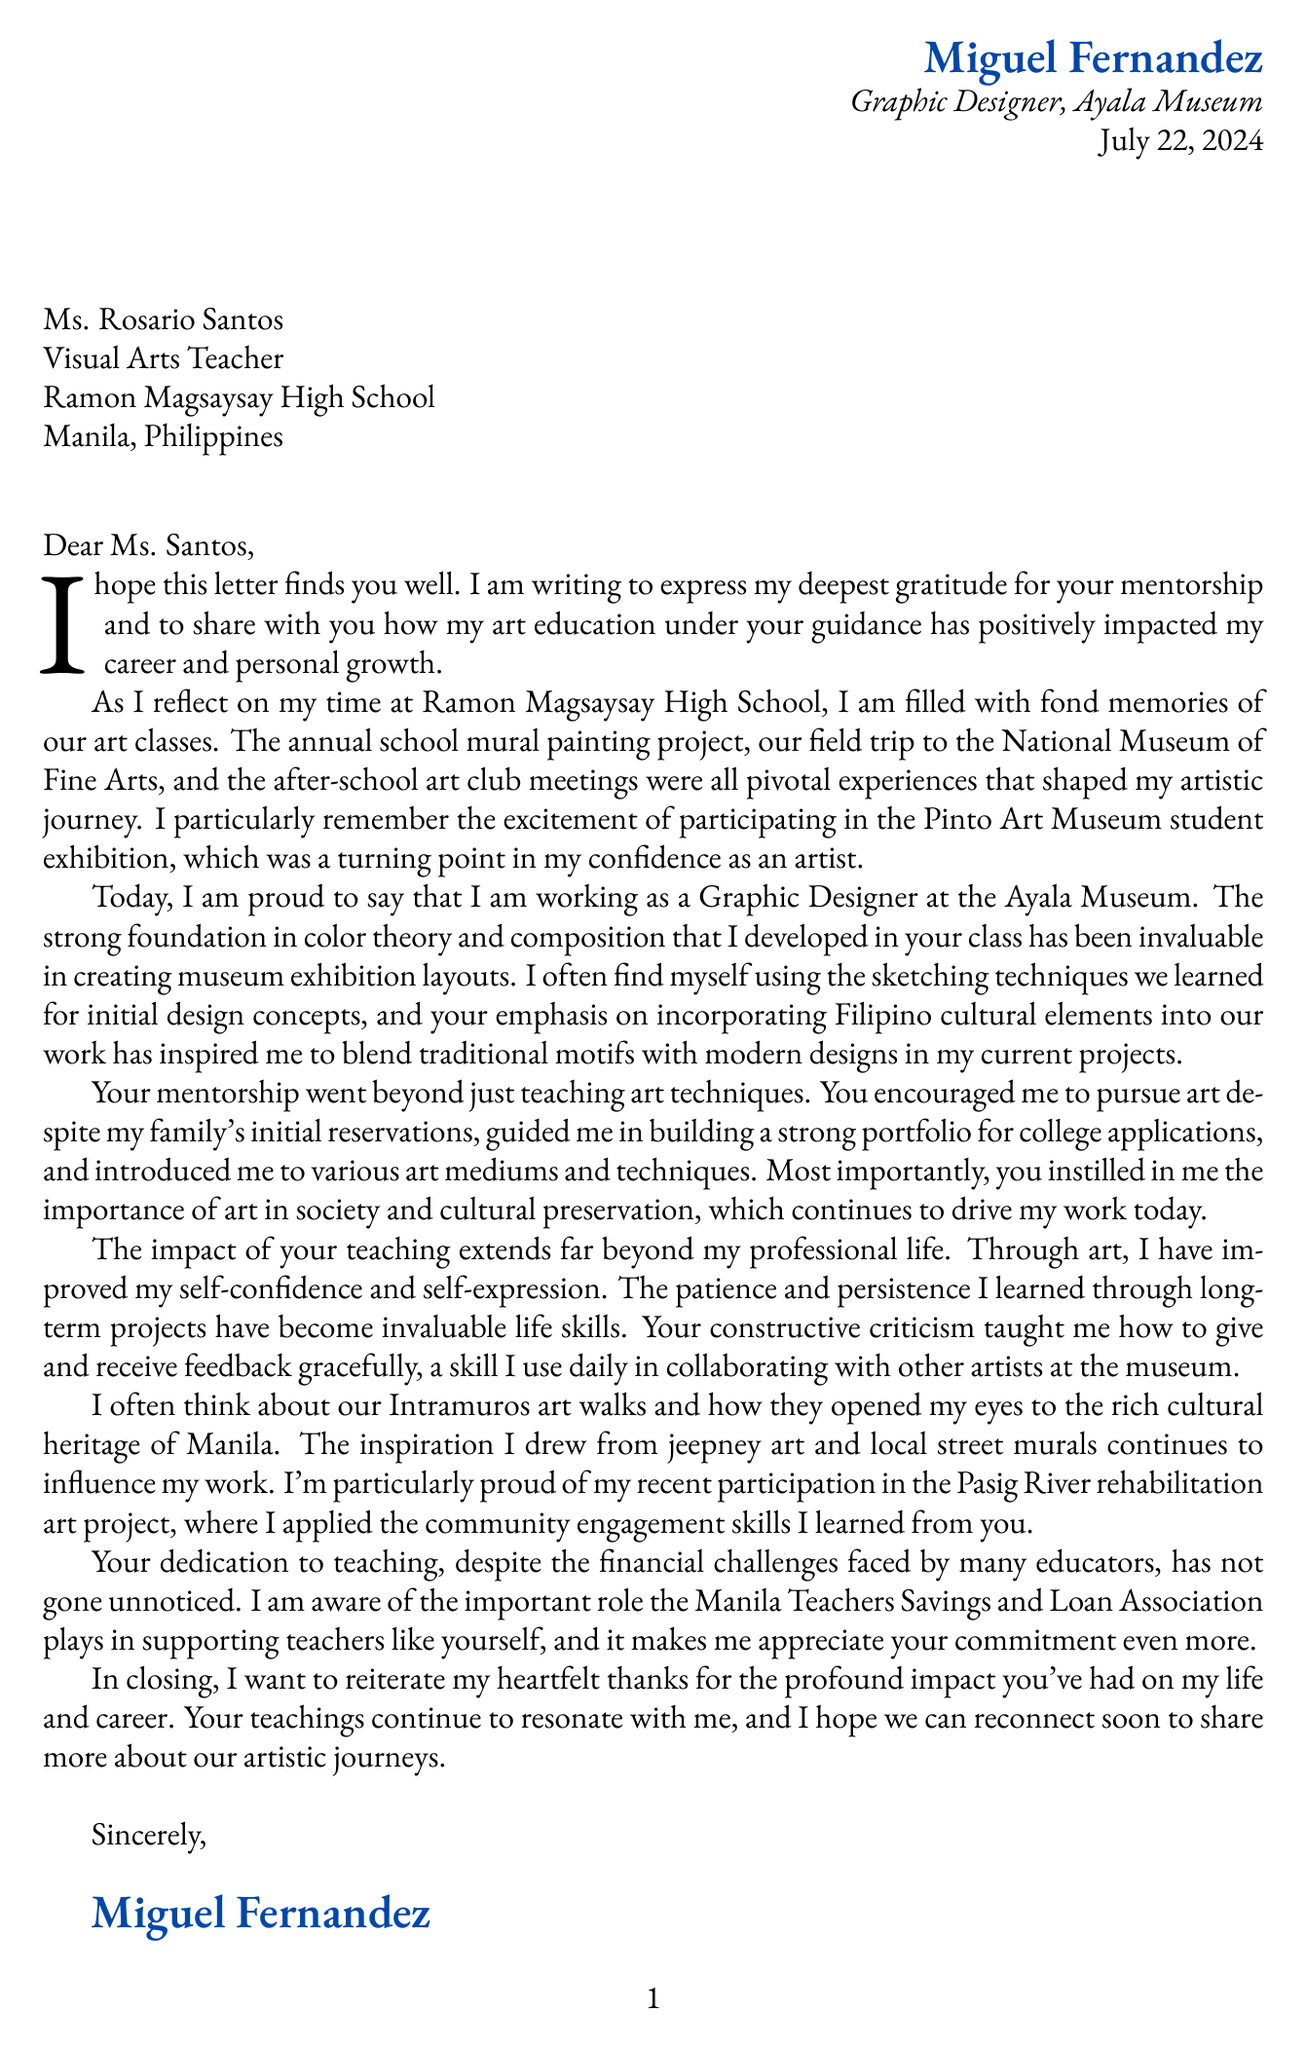What is the name of the former student? The letter begins with the name of the student, which is Miguel Fernandez.
Answer: Miguel Fernandez What is the teacher's name? The letter addresses the teacher as Ms. Rosario Santos.
Answer: Ms. Rosario Santos What year did the student graduate? The document mentions that the student graduated in the year 2015.
Answer: 2015 What is Miguel's current career? The letter states that Miguel is a Graphic Designer at the Ayala Museum.
Answer: Graphic Designer at Ayala Museum Which project does Miguel recall as a pivotal experience? The letter highlights the annual school mural painting project as a significant memory.
Answer: Annual school mural painting project What subject did Ms. Santos teach? The document specifies that Ms. Santos taught Visual Arts.
Answer: Visual Arts How did the teacher's mentorship impact the student's portfolio? The letter notes that the teacher guided Miguel in building a strong portfolio for college applications.
Answer: Building a strong portfolio What cultural element has influenced Miguel's current designs? The letter indicates that Miguel incorporates Filipino cultural elements into his designs.
Answer: Filipino cultural elements What financial organization is mentioned in the letter? The letter acknowledges the Manila Teachers Savings and Loan Association as supporting educators.
Answer: Manila Teachers Savings and Loan Association 